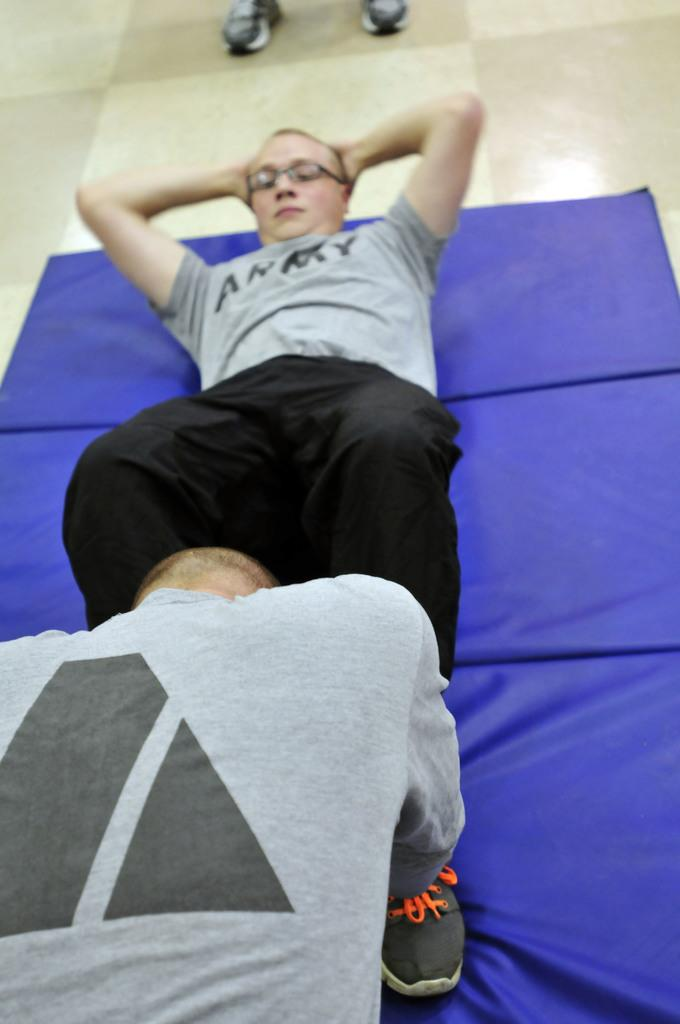How many people are present in the image? There are two people in the image. What are the two people doing in the image? The two people are doing exercises. What is placed on the floor in the image? There is a mat placed on the floor in the image. What type of poison is being used by the people in the image? There is no poison present in the image; the two people are doing exercises. How many planes can be seen in the image? There are no planes visible in the image; it features two people doing exercises on a mat. 